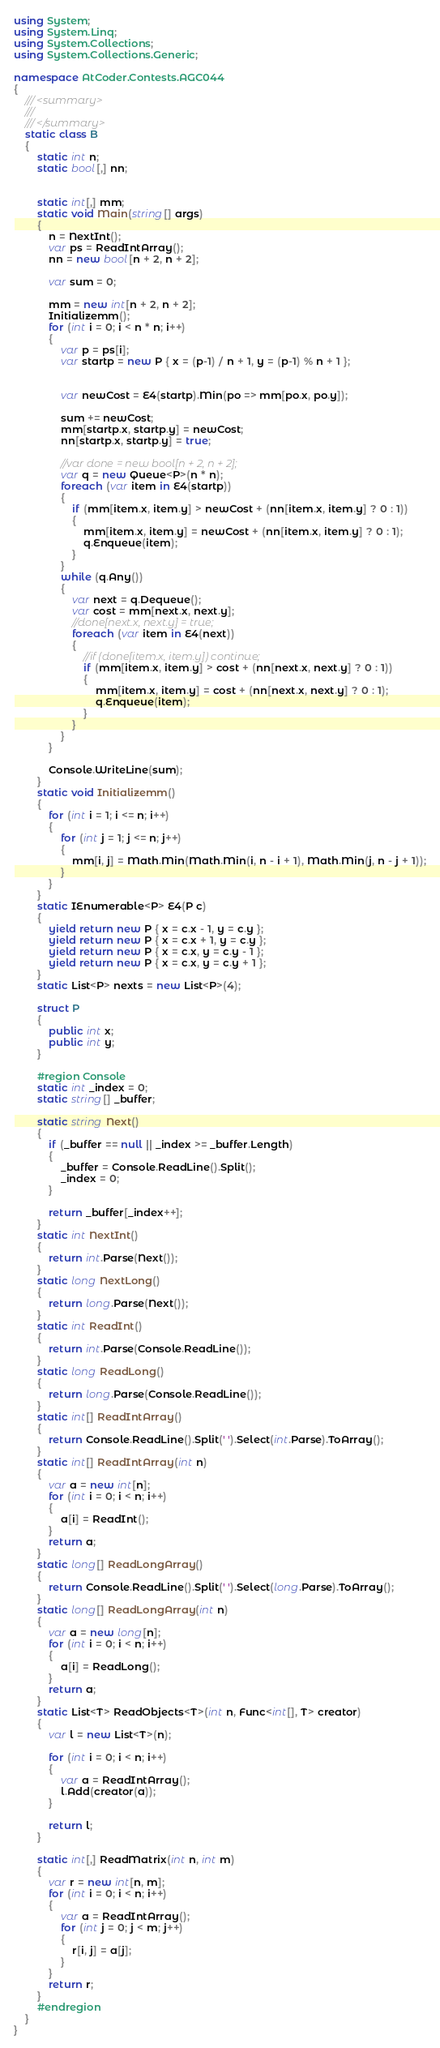Convert code to text. <code><loc_0><loc_0><loc_500><loc_500><_C#_>using System;
using System.Linq;
using System.Collections;
using System.Collections.Generic;

namespace AtCoder.Contests.AGC044
{
    /// <summary>
    /// 
    /// </summary>
    static class B
    {
        static int n;
        static bool[,] nn;


        static int[,] mm;
        static void Main(string[] args)
        {
            n = NextInt();
            var ps = ReadIntArray();
            nn = new bool[n + 2, n + 2];

            var sum = 0;

            mm = new int[n + 2, n + 2];
            Initializemm();
            for (int i = 0; i < n * n; i++)
            {
                var p = ps[i];
                var startp = new P { x = (p-1) / n + 1, y = (p-1) % n + 1 };


                var newCost = E4(startp).Min(po => mm[po.x, po.y]);

                sum += newCost;
                mm[startp.x, startp.y] = newCost;
                nn[startp.x, startp.y] = true;

                //var done = new bool[n + 2, n + 2];
                var q = new Queue<P>(n * n);
                foreach (var item in E4(startp))
                {
                    if (mm[item.x, item.y] > newCost + (nn[item.x, item.y] ? 0 : 1))
                    {
                        mm[item.x, item.y] = newCost + (nn[item.x, item.y] ? 0 : 1);
                        q.Enqueue(item);
                    }
                }
                while (q.Any())
                {
                    var next = q.Dequeue();
                    var cost = mm[next.x, next.y];
                    //done[next.x, next.y] = true;
                    foreach (var item in E4(next))
                    {
                        //if (done[item.x, item.y]) continue;
                        if (mm[item.x, item.y] > cost + (nn[next.x, next.y] ? 0 : 1))
                        {
                            mm[item.x, item.y] = cost + (nn[next.x, next.y] ? 0 : 1);
                            q.Enqueue(item);
                        }
                    }
                }
            }

            Console.WriteLine(sum);
        }
        static void Initializemm()
        {
            for (int i = 1; i <= n; i++)
            {
                for (int j = 1; j <= n; j++)
                {
                    mm[i, j] = Math.Min(Math.Min(i, n - i + 1), Math.Min(j, n - j + 1));
                }
            }
        }
        static IEnumerable<P> E4(P c)
        {
            yield return new P { x = c.x - 1, y = c.y };
            yield return new P { x = c.x + 1, y = c.y };
            yield return new P { x = c.x, y = c.y - 1 };
            yield return new P { x = c.x, y = c.y + 1 };
        }
        static List<P> nexts = new List<P>(4);

        struct P
        {
            public int x;
            public int y;
        }

        #region Console
        static int _index = 0;
        static string[] _buffer;

        static string Next()
        {
            if (_buffer == null || _index >= _buffer.Length)
            {
                _buffer = Console.ReadLine().Split();
                _index = 0;
            }

            return _buffer[_index++];
        }
        static int NextInt()
        {
            return int.Parse(Next());
        }
        static long NextLong()
        {
            return long.Parse(Next());
        }
        static int ReadInt()
        {
            return int.Parse(Console.ReadLine());
        }
        static long ReadLong()
        {
            return long.Parse(Console.ReadLine());
        }
        static int[] ReadIntArray()
        {
            return Console.ReadLine().Split(' ').Select(int.Parse).ToArray();
        }
        static int[] ReadIntArray(int n)
        {
            var a = new int[n];
            for (int i = 0; i < n; i++)
            {
                a[i] = ReadInt();
            }
            return a;
        }
        static long[] ReadLongArray()
        {
            return Console.ReadLine().Split(' ').Select(long.Parse).ToArray();
        }
        static long[] ReadLongArray(int n)
        {
            var a = new long[n];
            for (int i = 0; i < n; i++)
            {
                a[i] = ReadLong();
            }
            return a;
        }
        static List<T> ReadObjects<T>(int n, Func<int[], T> creator)
        {
            var l = new List<T>(n);

            for (int i = 0; i < n; i++)
            {
                var a = ReadIntArray();
                l.Add(creator(a));
            }

            return l;
        }

        static int[,] ReadMatrix(int n, int m)
        {
            var r = new int[n, m];
            for (int i = 0; i < n; i++)
            {
                var a = ReadIntArray();
                for (int j = 0; j < m; j++)
                {
                    r[i, j] = a[j];
                }
            }
            return r;
        }
        #endregion
    }
}
</code> 